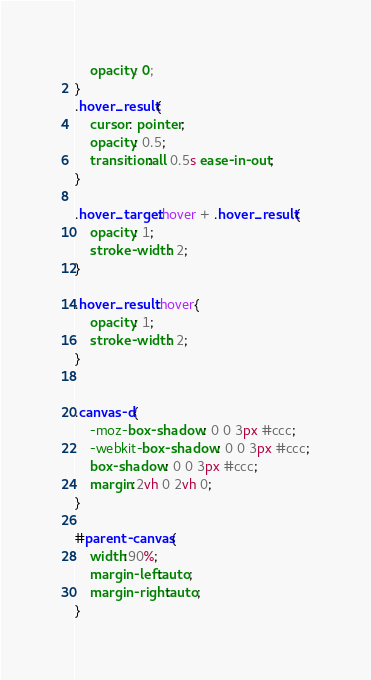<code> <loc_0><loc_0><loc_500><loc_500><_CSS_>    opacity: 0;
}
.hover_result{
    cursor: pointer;
    opacity: 0.5;
    transition:all 0.5s ease-in-out;
}

.hover_target:hover + .hover_result{
    opacity: 1;
    stroke-width: 2;
}

.hover_result:hover{
    opacity: 1;
    stroke-width: 2;
}


.canvas-d{
    -moz-box-shadow: 0 0 3px #ccc;
    -webkit-box-shadow: 0 0 3px #ccc;
    box-shadow: 0 0 3px #ccc;
    margin:2vh 0 2vh 0;
}

#parent-canvas{
    width:90%;
    margin-left:auto;
    margin-right:auto;
}</code> 